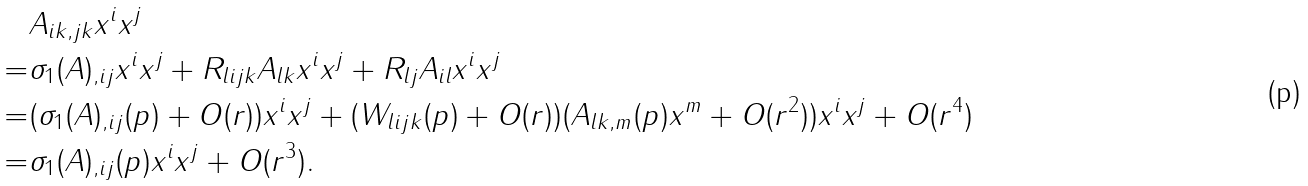Convert formula to latex. <formula><loc_0><loc_0><loc_500><loc_500>& A _ { i k , j k } x ^ { i } x ^ { j } \\ = & \sigma _ { 1 } ( A ) _ { , i j } x ^ { i } x ^ { j } + R _ { l i j k } A _ { l k } x ^ { i } x ^ { j } + R _ { l j } A _ { i l } x ^ { i } x ^ { j } \\ = & ( \sigma _ { 1 } ( A ) _ { , i j } ( p ) + O ( r ) ) x ^ { i } x ^ { j } + ( W _ { l i j k } ( p ) + O ( r ) ) ( A _ { l k , m } ( p ) x ^ { m } + O ( r ^ { 2 } ) ) x ^ { i } x ^ { j } + O ( r ^ { 4 } ) \\ = & \sigma _ { 1 } ( A ) _ { , i j } ( p ) x ^ { i } x ^ { j } + O ( r ^ { 3 } ) .</formula> 